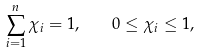<formula> <loc_0><loc_0><loc_500><loc_500>\sum _ { i = 1 } ^ { n } \chi _ { i } = 1 , \quad 0 \leq \chi _ { i } \leq 1 ,</formula> 